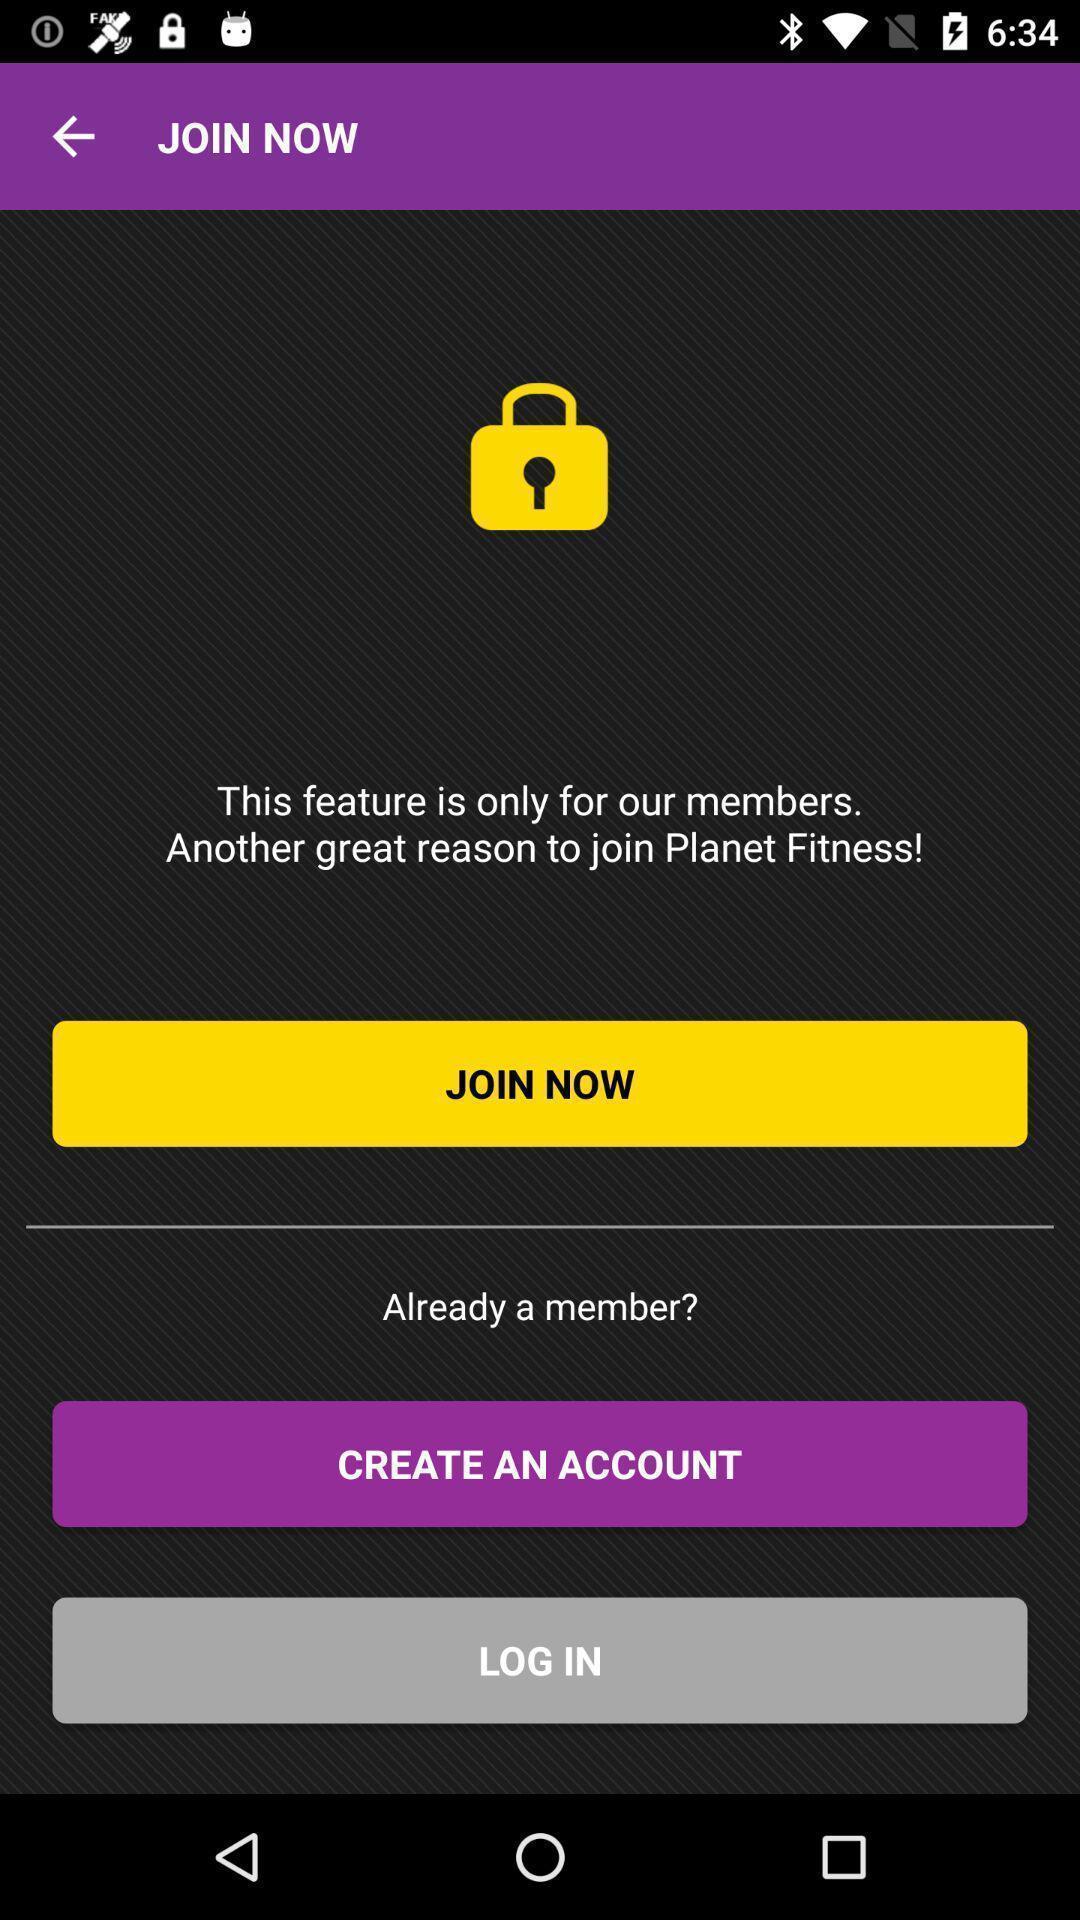What can you discern from this picture? Startup page of the application to get the access. 